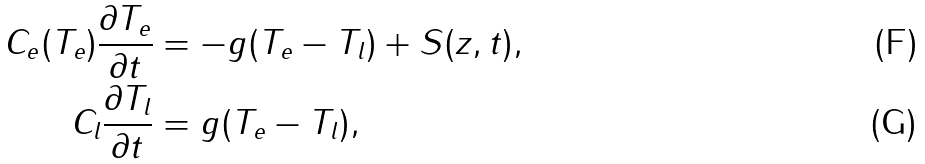<formula> <loc_0><loc_0><loc_500><loc_500>C _ { e } ( T _ { e } ) \frac { \partial T _ { e } } { \partial t } & = - g ( T _ { e } - T _ { l } ) + S ( z , t ) , \\ C _ { l } \frac { \partial T _ { l } } { \partial t } & = g ( T _ { e } - T _ { l } ) ,</formula> 